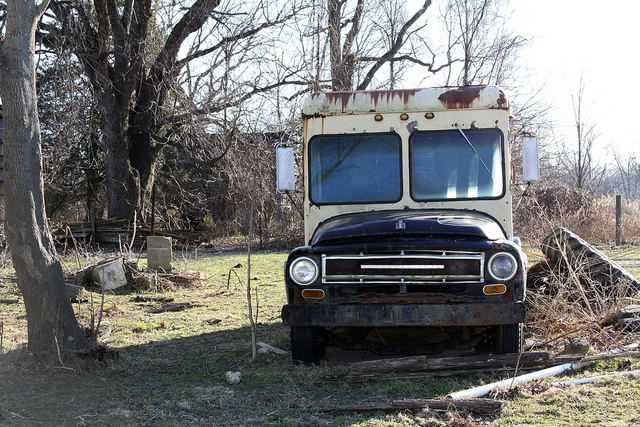Describe the objects in this image and their specific colors. I can see a truck in violet, black, darkgray, gray, and blue tones in this image. 